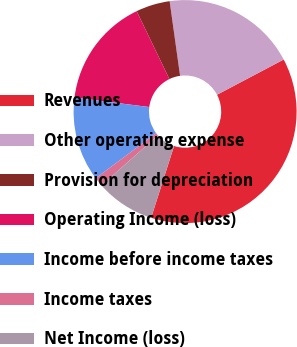Convert chart. <chart><loc_0><loc_0><loc_500><loc_500><pie_chart><fcel>Revenues<fcel>Other operating expense<fcel>Provision for depreciation<fcel>Operating Income (loss)<fcel>Income before income taxes<fcel>Income taxes<fcel>Net Income (loss)<nl><fcel>37.66%<fcel>19.48%<fcel>4.94%<fcel>15.84%<fcel>12.21%<fcel>1.3%<fcel>8.57%<nl></chart> 